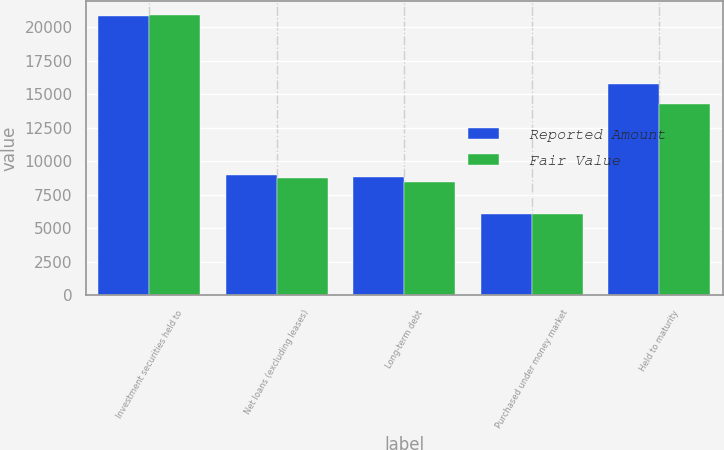Convert chart. <chart><loc_0><loc_0><loc_500><loc_500><stacked_bar_chart><ecel><fcel>Investment securities held to<fcel>Net loans (excluding leases)<fcel>Long-term debt<fcel>Purchased under money market<fcel>Held to maturity<nl><fcel>Reported Amount<fcel>20877<fcel>9013<fcel>8838<fcel>6087<fcel>15767<nl><fcel>Fair Value<fcel>20928<fcel>8729<fcel>8461<fcel>6101<fcel>14311<nl></chart> 